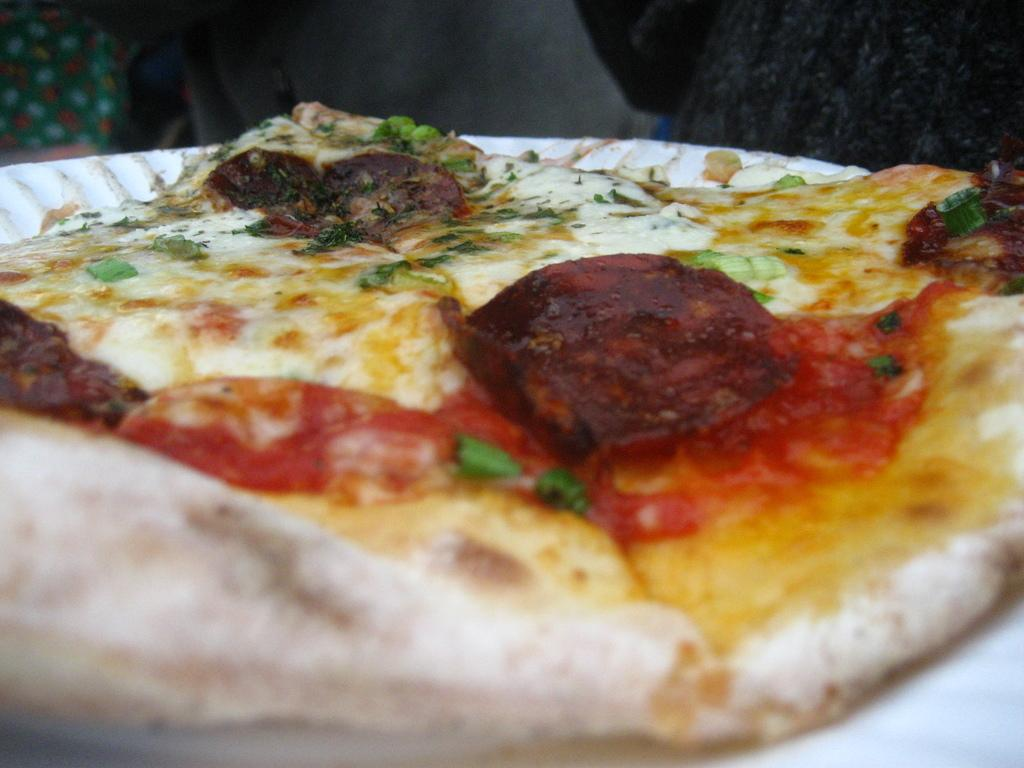What is the main subject of the image? There is an edible in the image. Can you describe any objects in the top corners of the image? Yes, there is a black object in the right top of the image and a green object in the left top of the image. What color is the background of the image? The background of the image is grey. How does the edible taste in the image? The taste of the edible cannot be determined from the image alone, as taste is a sensory experience. 